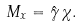<formula> <loc_0><loc_0><loc_500><loc_500>M _ { x } = \hat { \gamma } \, \chi .</formula> 